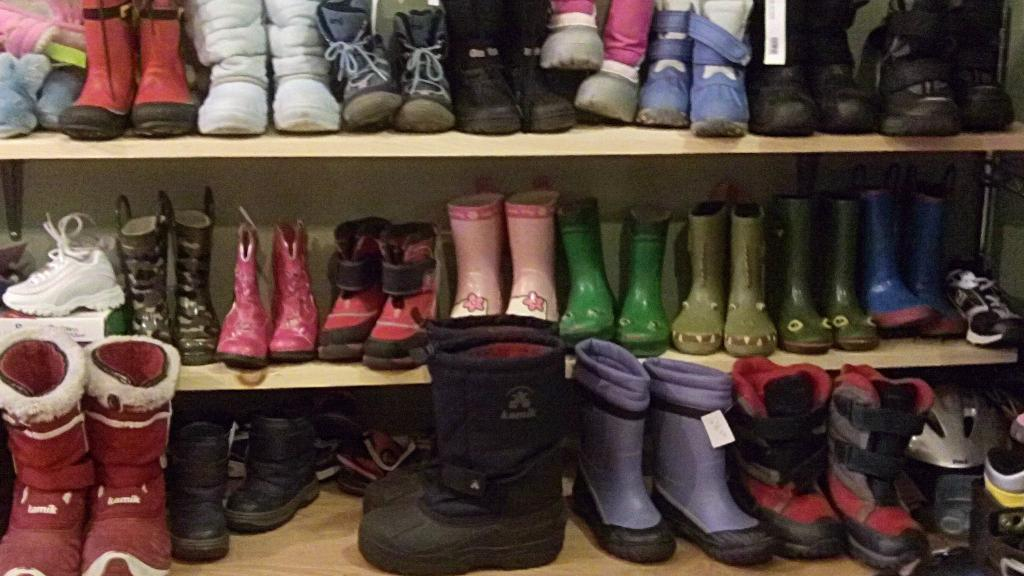What type of objects can be seen in the image? There are shoes in the image. How are the shoes arranged in the image? The shoes are organized in 3 racks. Can you describe the shoes in the middle of the image? There are black color big shoes in the middle of the image. What type of vessel is being used to transport the team in the image? There is no vessel or team present in the image; it only features shoes organized in racks. 